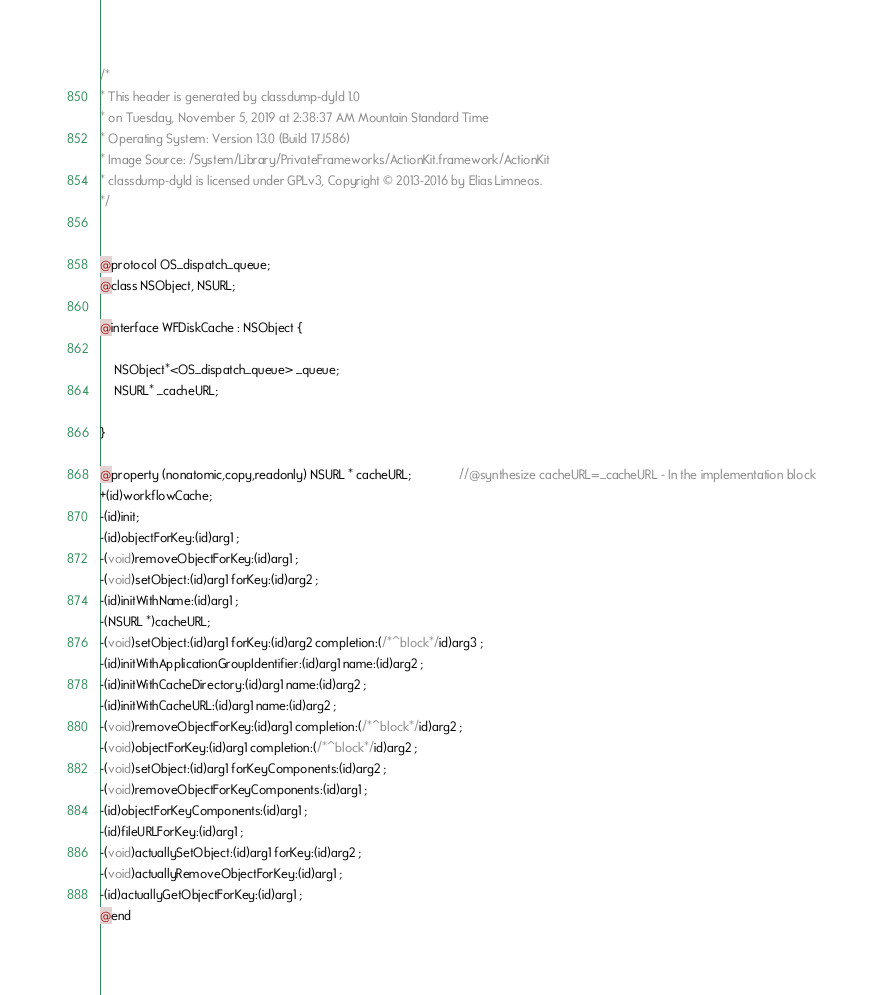Convert code to text. <code><loc_0><loc_0><loc_500><loc_500><_C_>/*
* This header is generated by classdump-dyld 1.0
* on Tuesday, November 5, 2019 at 2:38:37 AM Mountain Standard Time
* Operating System: Version 13.0 (Build 17J586)
* Image Source: /System/Library/PrivateFrameworks/ActionKit.framework/ActionKit
* classdump-dyld is licensed under GPLv3, Copyright © 2013-2016 by Elias Limneos.
*/


@protocol OS_dispatch_queue;
@class NSObject, NSURL;

@interface WFDiskCache : NSObject {

	NSObject*<OS_dispatch_queue> _queue;
	NSURL* _cacheURL;

}

@property (nonatomic,copy,readonly) NSURL * cacheURL;              //@synthesize cacheURL=_cacheURL - In the implementation block
+(id)workflowCache;
-(id)init;
-(id)objectForKey:(id)arg1 ;
-(void)removeObjectForKey:(id)arg1 ;
-(void)setObject:(id)arg1 forKey:(id)arg2 ;
-(id)initWithName:(id)arg1 ;
-(NSURL *)cacheURL;
-(void)setObject:(id)arg1 forKey:(id)arg2 completion:(/*^block*/id)arg3 ;
-(id)initWithApplicationGroupIdentifier:(id)arg1 name:(id)arg2 ;
-(id)initWithCacheDirectory:(id)arg1 name:(id)arg2 ;
-(id)initWithCacheURL:(id)arg1 name:(id)arg2 ;
-(void)removeObjectForKey:(id)arg1 completion:(/*^block*/id)arg2 ;
-(void)objectForKey:(id)arg1 completion:(/*^block*/id)arg2 ;
-(void)setObject:(id)arg1 forKeyComponents:(id)arg2 ;
-(void)removeObjectForKeyComponents:(id)arg1 ;
-(id)objectForKeyComponents:(id)arg1 ;
-(id)fileURLForKey:(id)arg1 ;
-(void)actuallySetObject:(id)arg1 forKey:(id)arg2 ;
-(void)actuallyRemoveObjectForKey:(id)arg1 ;
-(id)actuallyGetObjectForKey:(id)arg1 ;
@end

</code> 